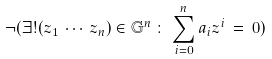Convert formula to latex. <formula><loc_0><loc_0><loc_500><loc_500>\neg ( \exists ! ( z _ { 1 } \, \cdots \, z _ { n } ) \in { \mathbb { G } } ^ { n } \, \colon \, \sum _ { i = 0 } ^ { n } a _ { i } z ^ { i } \, = \, 0 )</formula> 